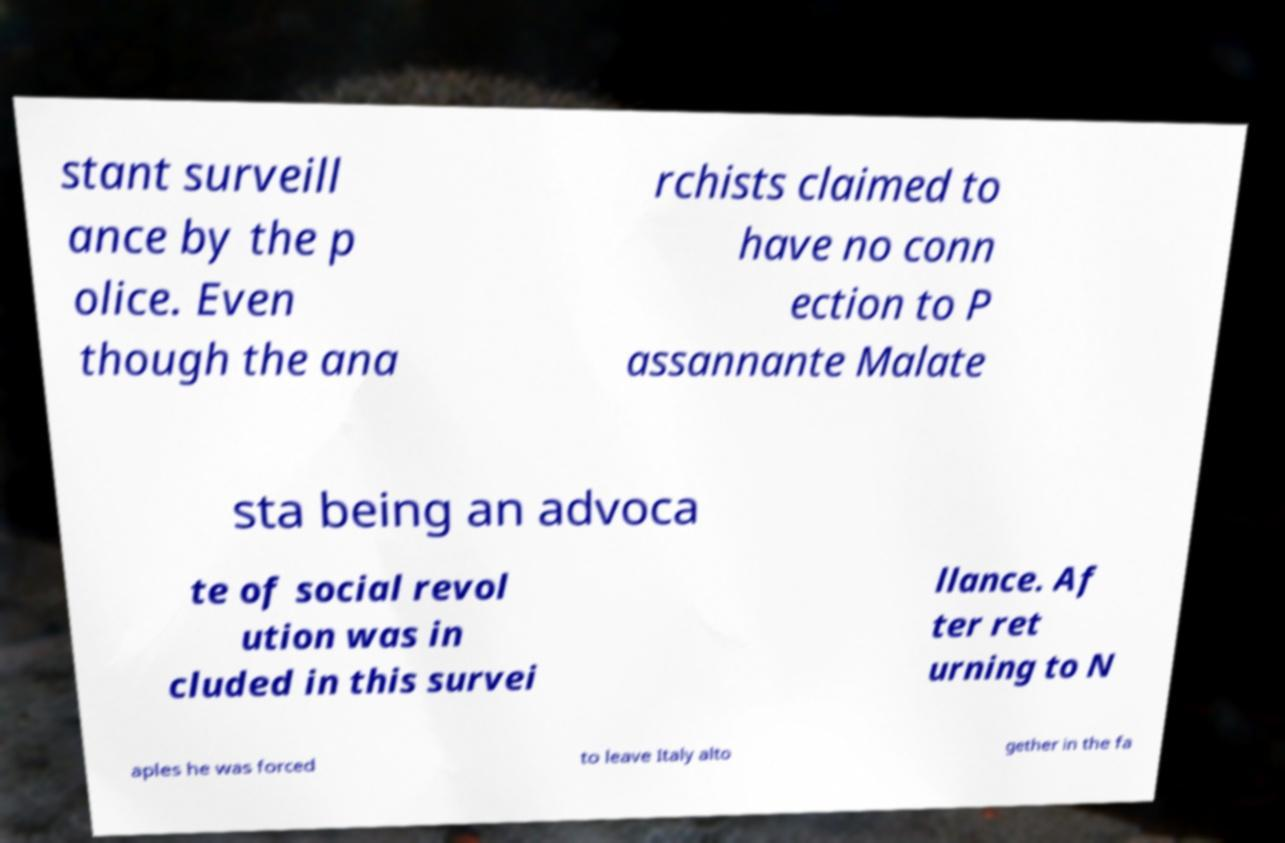Could you extract and type out the text from this image? stant surveill ance by the p olice. Even though the ana rchists claimed to have no conn ection to P assannante Malate sta being an advoca te of social revol ution was in cluded in this survei llance. Af ter ret urning to N aples he was forced to leave Italy alto gether in the fa 